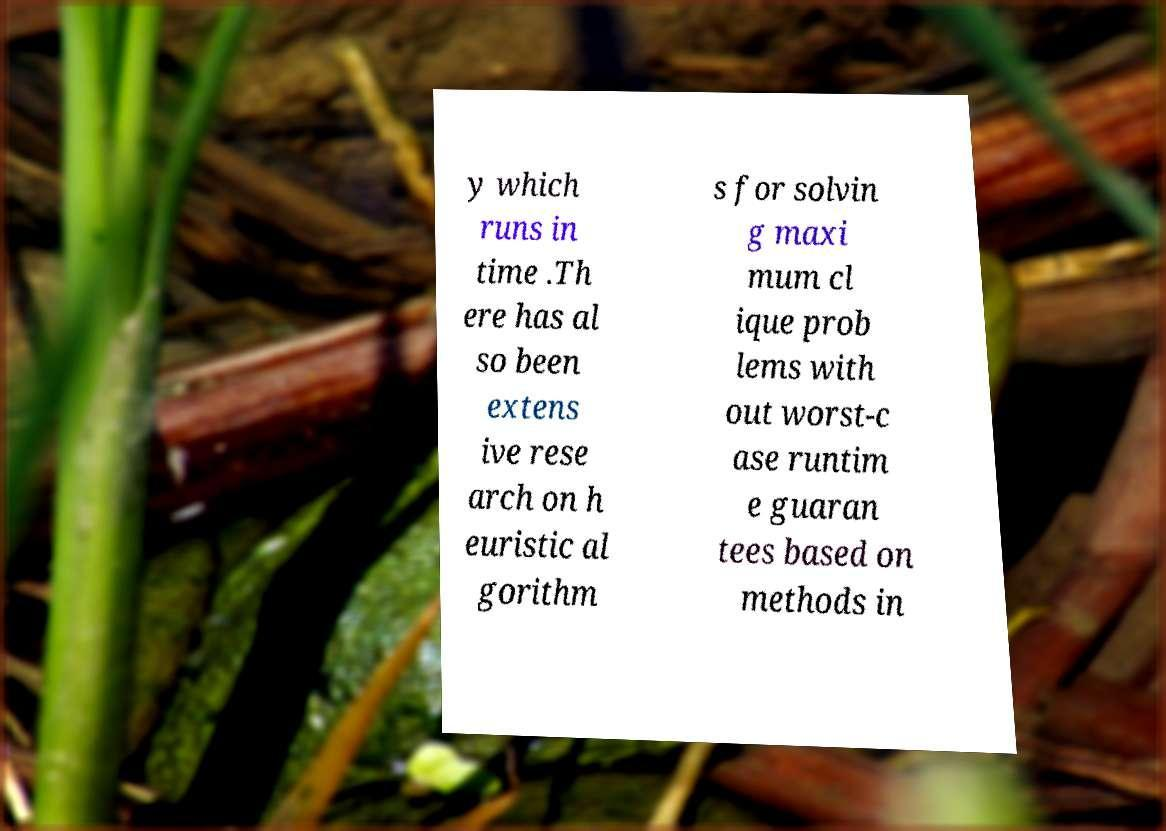Please read and relay the text visible in this image. What does it say? y which runs in time .Th ere has al so been extens ive rese arch on h euristic al gorithm s for solvin g maxi mum cl ique prob lems with out worst-c ase runtim e guaran tees based on methods in 